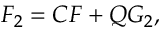<formula> <loc_0><loc_0><loc_500><loc_500>F _ { 2 } = C F + Q G _ { 2 } ,</formula> 